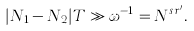Convert formula to latex. <formula><loc_0><loc_0><loc_500><loc_500>| N _ { 1 } - N _ { 2 } | T \gg \omega ^ { - 1 } = N ^ { s r ^ { \prime } } .</formula> 